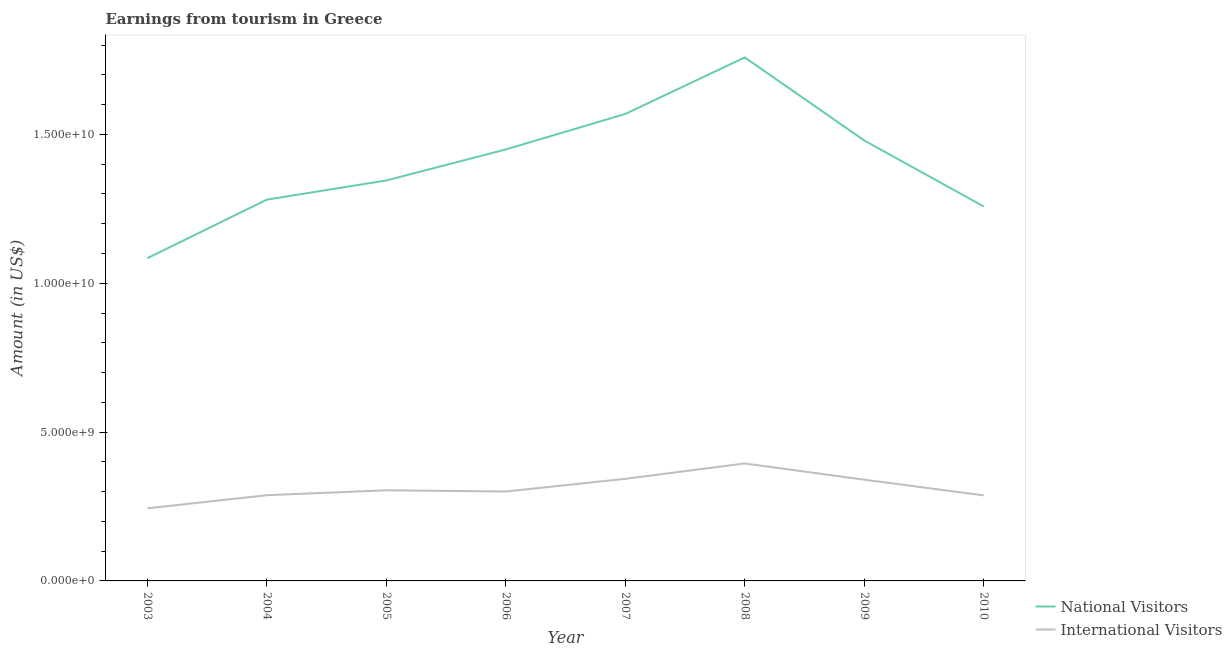Is the number of lines equal to the number of legend labels?
Your response must be concise. Yes. What is the amount earned from international visitors in 2009?
Keep it short and to the point. 3.40e+09. Across all years, what is the maximum amount earned from national visitors?
Make the answer very short. 1.76e+1. Across all years, what is the minimum amount earned from international visitors?
Give a very brief answer. 2.44e+09. In which year was the amount earned from national visitors maximum?
Your response must be concise. 2008. In which year was the amount earned from national visitors minimum?
Keep it short and to the point. 2003. What is the total amount earned from international visitors in the graph?
Your answer should be very brief. 2.50e+1. What is the difference between the amount earned from international visitors in 2007 and that in 2010?
Provide a short and direct response. 5.56e+08. What is the difference between the amount earned from international visitors in 2005 and the amount earned from national visitors in 2009?
Provide a succinct answer. -1.18e+1. What is the average amount earned from national visitors per year?
Provide a short and direct response. 1.40e+1. In the year 2008, what is the difference between the amount earned from international visitors and amount earned from national visitors?
Provide a short and direct response. -1.36e+1. In how many years, is the amount earned from international visitors greater than 14000000000 US$?
Make the answer very short. 0. What is the ratio of the amount earned from international visitors in 2005 to that in 2010?
Your answer should be compact. 1.06. Is the amount earned from international visitors in 2005 less than that in 2007?
Give a very brief answer. Yes. Is the difference between the amount earned from international visitors in 2007 and 2009 greater than the difference between the amount earned from national visitors in 2007 and 2009?
Provide a succinct answer. No. What is the difference between the highest and the second highest amount earned from national visitors?
Give a very brief answer. 1.90e+09. What is the difference between the highest and the lowest amount earned from international visitors?
Your answer should be very brief. 1.51e+09. In how many years, is the amount earned from national visitors greater than the average amount earned from national visitors taken over all years?
Provide a succinct answer. 4. Is the sum of the amount earned from national visitors in 2003 and 2008 greater than the maximum amount earned from international visitors across all years?
Your response must be concise. Yes. Does the amount earned from international visitors monotonically increase over the years?
Make the answer very short. No. How many lines are there?
Give a very brief answer. 2. How many years are there in the graph?
Give a very brief answer. 8. What is the difference between two consecutive major ticks on the Y-axis?
Ensure brevity in your answer.  5.00e+09. Are the values on the major ticks of Y-axis written in scientific E-notation?
Your response must be concise. Yes. How many legend labels are there?
Your answer should be very brief. 2. What is the title of the graph?
Your answer should be very brief. Earnings from tourism in Greece. Does "Crop" appear as one of the legend labels in the graph?
Your answer should be very brief. No. What is the Amount (in US$) of National Visitors in 2003?
Offer a terse response. 1.08e+1. What is the Amount (in US$) of International Visitors in 2003?
Keep it short and to the point. 2.44e+09. What is the Amount (in US$) of National Visitors in 2004?
Your response must be concise. 1.28e+1. What is the Amount (in US$) in International Visitors in 2004?
Your answer should be compact. 2.88e+09. What is the Amount (in US$) in National Visitors in 2005?
Make the answer very short. 1.35e+1. What is the Amount (in US$) of International Visitors in 2005?
Your answer should be very brief. 3.04e+09. What is the Amount (in US$) of National Visitors in 2006?
Provide a short and direct response. 1.45e+1. What is the Amount (in US$) of International Visitors in 2006?
Provide a short and direct response. 3.00e+09. What is the Amount (in US$) in National Visitors in 2007?
Ensure brevity in your answer.  1.57e+1. What is the Amount (in US$) of International Visitors in 2007?
Offer a very short reply. 3.43e+09. What is the Amount (in US$) in National Visitors in 2008?
Your answer should be compact. 1.76e+1. What is the Amount (in US$) of International Visitors in 2008?
Give a very brief answer. 3.95e+09. What is the Amount (in US$) in National Visitors in 2009?
Keep it short and to the point. 1.48e+1. What is the Amount (in US$) in International Visitors in 2009?
Ensure brevity in your answer.  3.40e+09. What is the Amount (in US$) of National Visitors in 2010?
Keep it short and to the point. 1.26e+1. What is the Amount (in US$) in International Visitors in 2010?
Offer a very short reply. 2.87e+09. Across all years, what is the maximum Amount (in US$) of National Visitors?
Offer a very short reply. 1.76e+1. Across all years, what is the maximum Amount (in US$) of International Visitors?
Provide a short and direct response. 3.95e+09. Across all years, what is the minimum Amount (in US$) in National Visitors?
Offer a very short reply. 1.08e+1. Across all years, what is the minimum Amount (in US$) of International Visitors?
Offer a very short reply. 2.44e+09. What is the total Amount (in US$) of National Visitors in the graph?
Your answer should be compact. 1.12e+11. What is the total Amount (in US$) of International Visitors in the graph?
Your answer should be compact. 2.50e+1. What is the difference between the Amount (in US$) of National Visitors in 2003 and that in 2004?
Offer a terse response. -1.97e+09. What is the difference between the Amount (in US$) of International Visitors in 2003 and that in 2004?
Keep it short and to the point. -4.41e+08. What is the difference between the Amount (in US$) in National Visitors in 2003 and that in 2005?
Your response must be concise. -2.61e+09. What is the difference between the Amount (in US$) in International Visitors in 2003 and that in 2005?
Offer a very short reply. -6.06e+08. What is the difference between the Amount (in US$) of National Visitors in 2003 and that in 2006?
Your answer should be very brief. -3.65e+09. What is the difference between the Amount (in US$) of International Visitors in 2003 and that in 2006?
Ensure brevity in your answer.  -5.65e+08. What is the difference between the Amount (in US$) in National Visitors in 2003 and that in 2007?
Your response must be concise. -4.84e+09. What is the difference between the Amount (in US$) in International Visitors in 2003 and that in 2007?
Ensure brevity in your answer.  -9.91e+08. What is the difference between the Amount (in US$) in National Visitors in 2003 and that in 2008?
Give a very brief answer. -6.74e+09. What is the difference between the Amount (in US$) in International Visitors in 2003 and that in 2008?
Your answer should be very brief. -1.51e+09. What is the difference between the Amount (in US$) in National Visitors in 2003 and that in 2009?
Ensure brevity in your answer.  -3.95e+09. What is the difference between the Amount (in US$) in International Visitors in 2003 and that in 2009?
Ensure brevity in your answer.  -9.62e+08. What is the difference between the Amount (in US$) of National Visitors in 2003 and that in 2010?
Provide a succinct answer. -1.74e+09. What is the difference between the Amount (in US$) in International Visitors in 2003 and that in 2010?
Provide a succinct answer. -4.35e+08. What is the difference between the Amount (in US$) in National Visitors in 2004 and that in 2005?
Keep it short and to the point. -6.44e+08. What is the difference between the Amount (in US$) of International Visitors in 2004 and that in 2005?
Provide a succinct answer. -1.65e+08. What is the difference between the Amount (in US$) in National Visitors in 2004 and that in 2006?
Make the answer very short. -1.69e+09. What is the difference between the Amount (in US$) in International Visitors in 2004 and that in 2006?
Provide a short and direct response. -1.24e+08. What is the difference between the Amount (in US$) of National Visitors in 2004 and that in 2007?
Provide a succinct answer. -2.88e+09. What is the difference between the Amount (in US$) in International Visitors in 2004 and that in 2007?
Keep it short and to the point. -5.50e+08. What is the difference between the Amount (in US$) in National Visitors in 2004 and that in 2008?
Your answer should be very brief. -4.78e+09. What is the difference between the Amount (in US$) of International Visitors in 2004 and that in 2008?
Offer a very short reply. -1.07e+09. What is the difference between the Amount (in US$) of National Visitors in 2004 and that in 2009?
Make the answer very short. -1.99e+09. What is the difference between the Amount (in US$) of International Visitors in 2004 and that in 2009?
Your response must be concise. -5.21e+08. What is the difference between the Amount (in US$) in National Visitors in 2004 and that in 2010?
Your answer should be compact. 2.30e+08. What is the difference between the Amount (in US$) of International Visitors in 2004 and that in 2010?
Make the answer very short. 6.00e+06. What is the difference between the Amount (in US$) in National Visitors in 2005 and that in 2006?
Make the answer very short. -1.04e+09. What is the difference between the Amount (in US$) of International Visitors in 2005 and that in 2006?
Your answer should be very brief. 4.10e+07. What is the difference between the Amount (in US$) of National Visitors in 2005 and that in 2007?
Offer a terse response. -2.23e+09. What is the difference between the Amount (in US$) in International Visitors in 2005 and that in 2007?
Offer a very short reply. -3.85e+08. What is the difference between the Amount (in US$) in National Visitors in 2005 and that in 2008?
Your answer should be compact. -4.13e+09. What is the difference between the Amount (in US$) of International Visitors in 2005 and that in 2008?
Provide a short and direct response. -9.01e+08. What is the difference between the Amount (in US$) of National Visitors in 2005 and that in 2009?
Your response must be concise. -1.34e+09. What is the difference between the Amount (in US$) in International Visitors in 2005 and that in 2009?
Make the answer very short. -3.56e+08. What is the difference between the Amount (in US$) of National Visitors in 2005 and that in 2010?
Provide a succinct answer. 8.74e+08. What is the difference between the Amount (in US$) in International Visitors in 2005 and that in 2010?
Your answer should be compact. 1.71e+08. What is the difference between the Amount (in US$) of National Visitors in 2006 and that in 2007?
Offer a terse response. -1.19e+09. What is the difference between the Amount (in US$) in International Visitors in 2006 and that in 2007?
Make the answer very short. -4.26e+08. What is the difference between the Amount (in US$) in National Visitors in 2006 and that in 2008?
Provide a short and direct response. -3.09e+09. What is the difference between the Amount (in US$) in International Visitors in 2006 and that in 2008?
Offer a terse response. -9.42e+08. What is the difference between the Amount (in US$) in National Visitors in 2006 and that in 2009?
Provide a short and direct response. -3.01e+08. What is the difference between the Amount (in US$) of International Visitors in 2006 and that in 2009?
Offer a very short reply. -3.97e+08. What is the difference between the Amount (in US$) of National Visitors in 2006 and that in 2010?
Ensure brevity in your answer.  1.92e+09. What is the difference between the Amount (in US$) in International Visitors in 2006 and that in 2010?
Provide a succinct answer. 1.30e+08. What is the difference between the Amount (in US$) of National Visitors in 2007 and that in 2008?
Give a very brief answer. -1.90e+09. What is the difference between the Amount (in US$) of International Visitors in 2007 and that in 2008?
Keep it short and to the point. -5.16e+08. What is the difference between the Amount (in US$) of National Visitors in 2007 and that in 2009?
Make the answer very short. 8.91e+08. What is the difference between the Amount (in US$) of International Visitors in 2007 and that in 2009?
Provide a succinct answer. 2.90e+07. What is the difference between the Amount (in US$) in National Visitors in 2007 and that in 2010?
Offer a terse response. 3.11e+09. What is the difference between the Amount (in US$) of International Visitors in 2007 and that in 2010?
Offer a terse response. 5.56e+08. What is the difference between the Amount (in US$) of National Visitors in 2008 and that in 2009?
Ensure brevity in your answer.  2.79e+09. What is the difference between the Amount (in US$) of International Visitors in 2008 and that in 2009?
Make the answer very short. 5.45e+08. What is the difference between the Amount (in US$) in National Visitors in 2008 and that in 2010?
Your answer should be very brief. 5.01e+09. What is the difference between the Amount (in US$) in International Visitors in 2008 and that in 2010?
Give a very brief answer. 1.07e+09. What is the difference between the Amount (in US$) of National Visitors in 2009 and that in 2010?
Provide a short and direct response. 2.22e+09. What is the difference between the Amount (in US$) in International Visitors in 2009 and that in 2010?
Offer a very short reply. 5.27e+08. What is the difference between the Amount (in US$) in National Visitors in 2003 and the Amount (in US$) in International Visitors in 2004?
Your response must be concise. 7.96e+09. What is the difference between the Amount (in US$) of National Visitors in 2003 and the Amount (in US$) of International Visitors in 2005?
Your answer should be compact. 7.80e+09. What is the difference between the Amount (in US$) in National Visitors in 2003 and the Amount (in US$) in International Visitors in 2006?
Keep it short and to the point. 7.84e+09. What is the difference between the Amount (in US$) in National Visitors in 2003 and the Amount (in US$) in International Visitors in 2007?
Provide a succinct answer. 7.41e+09. What is the difference between the Amount (in US$) of National Visitors in 2003 and the Amount (in US$) of International Visitors in 2008?
Your answer should be compact. 6.90e+09. What is the difference between the Amount (in US$) of National Visitors in 2003 and the Amount (in US$) of International Visitors in 2009?
Provide a succinct answer. 7.44e+09. What is the difference between the Amount (in US$) in National Visitors in 2003 and the Amount (in US$) in International Visitors in 2010?
Your answer should be very brief. 7.97e+09. What is the difference between the Amount (in US$) of National Visitors in 2004 and the Amount (in US$) of International Visitors in 2005?
Provide a short and direct response. 9.76e+09. What is the difference between the Amount (in US$) in National Visitors in 2004 and the Amount (in US$) in International Visitors in 2006?
Your response must be concise. 9.80e+09. What is the difference between the Amount (in US$) in National Visitors in 2004 and the Amount (in US$) in International Visitors in 2007?
Offer a very short reply. 9.38e+09. What is the difference between the Amount (in US$) of National Visitors in 2004 and the Amount (in US$) of International Visitors in 2008?
Provide a short and direct response. 8.86e+09. What is the difference between the Amount (in US$) in National Visitors in 2004 and the Amount (in US$) in International Visitors in 2009?
Ensure brevity in your answer.  9.41e+09. What is the difference between the Amount (in US$) of National Visitors in 2004 and the Amount (in US$) of International Visitors in 2010?
Provide a succinct answer. 9.94e+09. What is the difference between the Amount (in US$) of National Visitors in 2005 and the Amount (in US$) of International Visitors in 2006?
Ensure brevity in your answer.  1.04e+1. What is the difference between the Amount (in US$) of National Visitors in 2005 and the Amount (in US$) of International Visitors in 2007?
Give a very brief answer. 1.00e+1. What is the difference between the Amount (in US$) in National Visitors in 2005 and the Amount (in US$) in International Visitors in 2008?
Keep it short and to the point. 9.51e+09. What is the difference between the Amount (in US$) of National Visitors in 2005 and the Amount (in US$) of International Visitors in 2009?
Your answer should be very brief. 1.01e+1. What is the difference between the Amount (in US$) in National Visitors in 2005 and the Amount (in US$) in International Visitors in 2010?
Your answer should be very brief. 1.06e+1. What is the difference between the Amount (in US$) in National Visitors in 2006 and the Amount (in US$) in International Visitors in 2007?
Ensure brevity in your answer.  1.11e+1. What is the difference between the Amount (in US$) of National Visitors in 2006 and the Amount (in US$) of International Visitors in 2008?
Give a very brief answer. 1.05e+1. What is the difference between the Amount (in US$) of National Visitors in 2006 and the Amount (in US$) of International Visitors in 2009?
Provide a succinct answer. 1.11e+1. What is the difference between the Amount (in US$) in National Visitors in 2006 and the Amount (in US$) in International Visitors in 2010?
Provide a short and direct response. 1.16e+1. What is the difference between the Amount (in US$) of National Visitors in 2007 and the Amount (in US$) of International Visitors in 2008?
Give a very brief answer. 1.17e+1. What is the difference between the Amount (in US$) in National Visitors in 2007 and the Amount (in US$) in International Visitors in 2009?
Your answer should be very brief. 1.23e+1. What is the difference between the Amount (in US$) in National Visitors in 2007 and the Amount (in US$) in International Visitors in 2010?
Keep it short and to the point. 1.28e+1. What is the difference between the Amount (in US$) of National Visitors in 2008 and the Amount (in US$) of International Visitors in 2009?
Keep it short and to the point. 1.42e+1. What is the difference between the Amount (in US$) of National Visitors in 2008 and the Amount (in US$) of International Visitors in 2010?
Provide a short and direct response. 1.47e+1. What is the difference between the Amount (in US$) of National Visitors in 2009 and the Amount (in US$) of International Visitors in 2010?
Your answer should be compact. 1.19e+1. What is the average Amount (in US$) of National Visitors per year?
Your answer should be very brief. 1.40e+1. What is the average Amount (in US$) of International Visitors per year?
Provide a short and direct response. 3.13e+09. In the year 2003, what is the difference between the Amount (in US$) of National Visitors and Amount (in US$) of International Visitors?
Your response must be concise. 8.40e+09. In the year 2004, what is the difference between the Amount (in US$) in National Visitors and Amount (in US$) in International Visitors?
Give a very brief answer. 9.93e+09. In the year 2005, what is the difference between the Amount (in US$) of National Visitors and Amount (in US$) of International Visitors?
Your answer should be compact. 1.04e+1. In the year 2006, what is the difference between the Amount (in US$) in National Visitors and Amount (in US$) in International Visitors?
Make the answer very short. 1.15e+1. In the year 2007, what is the difference between the Amount (in US$) in National Visitors and Amount (in US$) in International Visitors?
Your answer should be compact. 1.23e+1. In the year 2008, what is the difference between the Amount (in US$) of National Visitors and Amount (in US$) of International Visitors?
Your answer should be compact. 1.36e+1. In the year 2009, what is the difference between the Amount (in US$) of National Visitors and Amount (in US$) of International Visitors?
Provide a succinct answer. 1.14e+1. In the year 2010, what is the difference between the Amount (in US$) in National Visitors and Amount (in US$) in International Visitors?
Your response must be concise. 9.70e+09. What is the ratio of the Amount (in US$) in National Visitors in 2003 to that in 2004?
Your answer should be very brief. 0.85. What is the ratio of the Amount (in US$) of International Visitors in 2003 to that in 2004?
Give a very brief answer. 0.85. What is the ratio of the Amount (in US$) of National Visitors in 2003 to that in 2005?
Provide a succinct answer. 0.81. What is the ratio of the Amount (in US$) of International Visitors in 2003 to that in 2005?
Provide a succinct answer. 0.8. What is the ratio of the Amount (in US$) of National Visitors in 2003 to that in 2006?
Provide a succinct answer. 0.75. What is the ratio of the Amount (in US$) in International Visitors in 2003 to that in 2006?
Provide a succinct answer. 0.81. What is the ratio of the Amount (in US$) in National Visitors in 2003 to that in 2007?
Offer a very short reply. 0.69. What is the ratio of the Amount (in US$) in International Visitors in 2003 to that in 2007?
Your response must be concise. 0.71. What is the ratio of the Amount (in US$) in National Visitors in 2003 to that in 2008?
Make the answer very short. 0.62. What is the ratio of the Amount (in US$) of International Visitors in 2003 to that in 2008?
Offer a terse response. 0.62. What is the ratio of the Amount (in US$) in National Visitors in 2003 to that in 2009?
Ensure brevity in your answer.  0.73. What is the ratio of the Amount (in US$) in International Visitors in 2003 to that in 2009?
Make the answer very short. 0.72. What is the ratio of the Amount (in US$) in National Visitors in 2003 to that in 2010?
Your response must be concise. 0.86. What is the ratio of the Amount (in US$) of International Visitors in 2003 to that in 2010?
Your response must be concise. 0.85. What is the ratio of the Amount (in US$) in National Visitors in 2004 to that in 2005?
Keep it short and to the point. 0.95. What is the ratio of the Amount (in US$) of International Visitors in 2004 to that in 2005?
Your answer should be very brief. 0.95. What is the ratio of the Amount (in US$) in National Visitors in 2004 to that in 2006?
Your answer should be very brief. 0.88. What is the ratio of the Amount (in US$) of International Visitors in 2004 to that in 2006?
Provide a short and direct response. 0.96. What is the ratio of the Amount (in US$) of National Visitors in 2004 to that in 2007?
Ensure brevity in your answer.  0.82. What is the ratio of the Amount (in US$) in International Visitors in 2004 to that in 2007?
Your answer should be very brief. 0.84. What is the ratio of the Amount (in US$) of National Visitors in 2004 to that in 2008?
Keep it short and to the point. 0.73. What is the ratio of the Amount (in US$) of International Visitors in 2004 to that in 2008?
Provide a short and direct response. 0.73. What is the ratio of the Amount (in US$) of National Visitors in 2004 to that in 2009?
Provide a succinct answer. 0.87. What is the ratio of the Amount (in US$) in International Visitors in 2004 to that in 2009?
Your answer should be very brief. 0.85. What is the ratio of the Amount (in US$) in National Visitors in 2004 to that in 2010?
Offer a very short reply. 1.02. What is the ratio of the Amount (in US$) in International Visitors in 2004 to that in 2010?
Offer a very short reply. 1. What is the ratio of the Amount (in US$) of National Visitors in 2005 to that in 2006?
Your answer should be very brief. 0.93. What is the ratio of the Amount (in US$) in International Visitors in 2005 to that in 2006?
Your answer should be compact. 1.01. What is the ratio of the Amount (in US$) of National Visitors in 2005 to that in 2007?
Ensure brevity in your answer.  0.86. What is the ratio of the Amount (in US$) of International Visitors in 2005 to that in 2007?
Provide a succinct answer. 0.89. What is the ratio of the Amount (in US$) of National Visitors in 2005 to that in 2008?
Your answer should be very brief. 0.77. What is the ratio of the Amount (in US$) of International Visitors in 2005 to that in 2008?
Provide a succinct answer. 0.77. What is the ratio of the Amount (in US$) of National Visitors in 2005 to that in 2009?
Make the answer very short. 0.91. What is the ratio of the Amount (in US$) in International Visitors in 2005 to that in 2009?
Keep it short and to the point. 0.9. What is the ratio of the Amount (in US$) in National Visitors in 2005 to that in 2010?
Give a very brief answer. 1.07. What is the ratio of the Amount (in US$) of International Visitors in 2005 to that in 2010?
Give a very brief answer. 1.06. What is the ratio of the Amount (in US$) of National Visitors in 2006 to that in 2007?
Keep it short and to the point. 0.92. What is the ratio of the Amount (in US$) in International Visitors in 2006 to that in 2007?
Your answer should be compact. 0.88. What is the ratio of the Amount (in US$) of National Visitors in 2006 to that in 2008?
Ensure brevity in your answer.  0.82. What is the ratio of the Amount (in US$) of International Visitors in 2006 to that in 2008?
Make the answer very short. 0.76. What is the ratio of the Amount (in US$) of National Visitors in 2006 to that in 2009?
Keep it short and to the point. 0.98. What is the ratio of the Amount (in US$) in International Visitors in 2006 to that in 2009?
Give a very brief answer. 0.88. What is the ratio of the Amount (in US$) of National Visitors in 2006 to that in 2010?
Your answer should be compact. 1.15. What is the ratio of the Amount (in US$) in International Visitors in 2006 to that in 2010?
Keep it short and to the point. 1.05. What is the ratio of the Amount (in US$) of National Visitors in 2007 to that in 2008?
Offer a terse response. 0.89. What is the ratio of the Amount (in US$) of International Visitors in 2007 to that in 2008?
Offer a very short reply. 0.87. What is the ratio of the Amount (in US$) of National Visitors in 2007 to that in 2009?
Provide a succinct answer. 1.06. What is the ratio of the Amount (in US$) in International Visitors in 2007 to that in 2009?
Offer a very short reply. 1.01. What is the ratio of the Amount (in US$) in National Visitors in 2007 to that in 2010?
Offer a very short reply. 1.25. What is the ratio of the Amount (in US$) in International Visitors in 2007 to that in 2010?
Provide a succinct answer. 1.19. What is the ratio of the Amount (in US$) in National Visitors in 2008 to that in 2009?
Provide a short and direct response. 1.19. What is the ratio of the Amount (in US$) in International Visitors in 2008 to that in 2009?
Make the answer very short. 1.16. What is the ratio of the Amount (in US$) of National Visitors in 2008 to that in 2010?
Offer a terse response. 1.4. What is the ratio of the Amount (in US$) in International Visitors in 2008 to that in 2010?
Provide a short and direct response. 1.37. What is the ratio of the Amount (in US$) of National Visitors in 2009 to that in 2010?
Offer a terse response. 1.18. What is the ratio of the Amount (in US$) in International Visitors in 2009 to that in 2010?
Ensure brevity in your answer.  1.18. What is the difference between the highest and the second highest Amount (in US$) of National Visitors?
Your response must be concise. 1.90e+09. What is the difference between the highest and the second highest Amount (in US$) in International Visitors?
Your answer should be very brief. 5.16e+08. What is the difference between the highest and the lowest Amount (in US$) of National Visitors?
Offer a terse response. 6.74e+09. What is the difference between the highest and the lowest Amount (in US$) in International Visitors?
Your answer should be compact. 1.51e+09. 